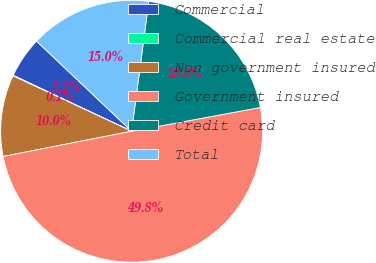Convert chart. <chart><loc_0><loc_0><loc_500><loc_500><pie_chart><fcel>Commercial<fcel>Commercial real estate<fcel>Non government insured<fcel>Government insured<fcel>Credit card<fcel>Total<nl><fcel>5.05%<fcel>0.07%<fcel>10.04%<fcel>49.82%<fcel>20.0%<fcel>15.02%<nl></chart> 